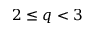Convert formula to latex. <formula><loc_0><loc_0><loc_500><loc_500>2 \leq q < 3</formula> 